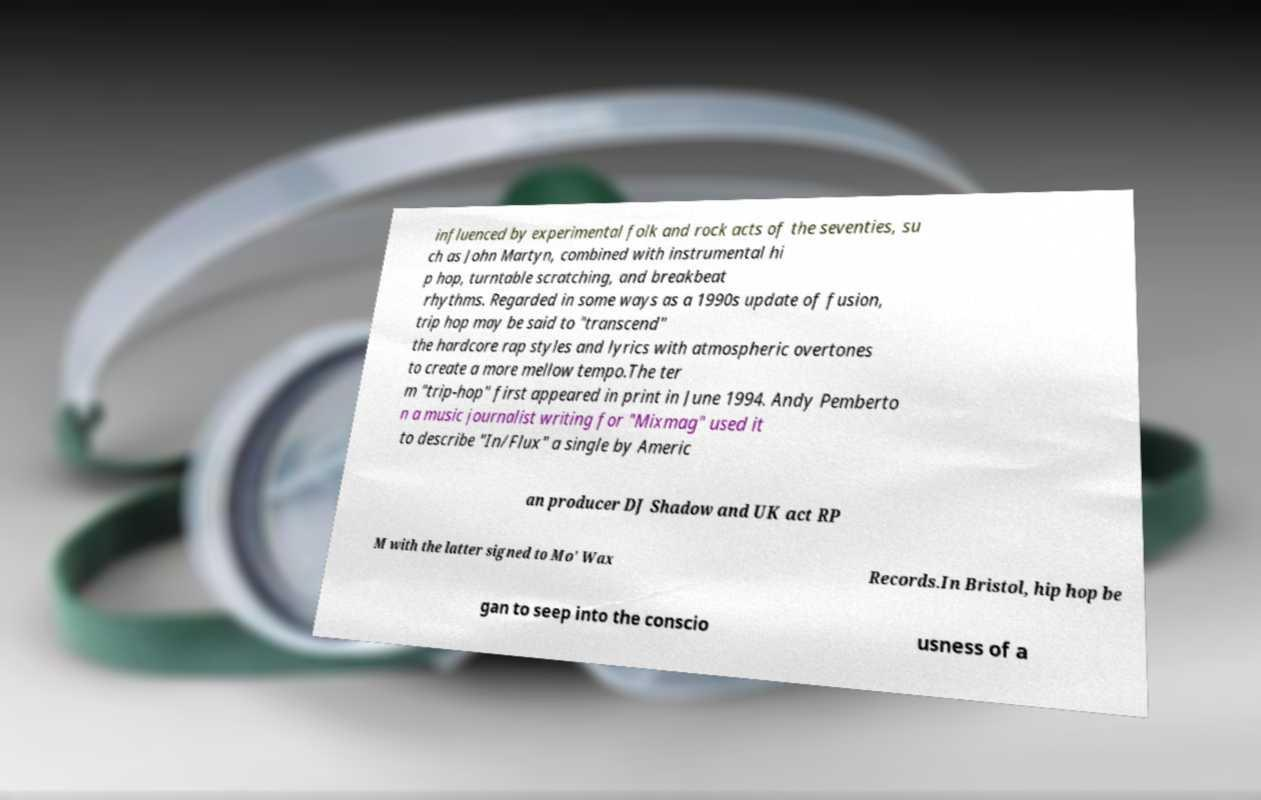I need the written content from this picture converted into text. Can you do that? influenced by experimental folk and rock acts of the seventies, su ch as John Martyn, combined with instrumental hi p hop, turntable scratching, and breakbeat rhythms. Regarded in some ways as a 1990s update of fusion, trip hop may be said to "transcend" the hardcore rap styles and lyrics with atmospheric overtones to create a more mellow tempo.The ter m "trip-hop" first appeared in print in June 1994. Andy Pemberto n a music journalist writing for "Mixmag" used it to describe "In/Flux" a single by Americ an producer DJ Shadow and UK act RP M with the latter signed to Mo' Wax Records.In Bristol, hip hop be gan to seep into the conscio usness of a 